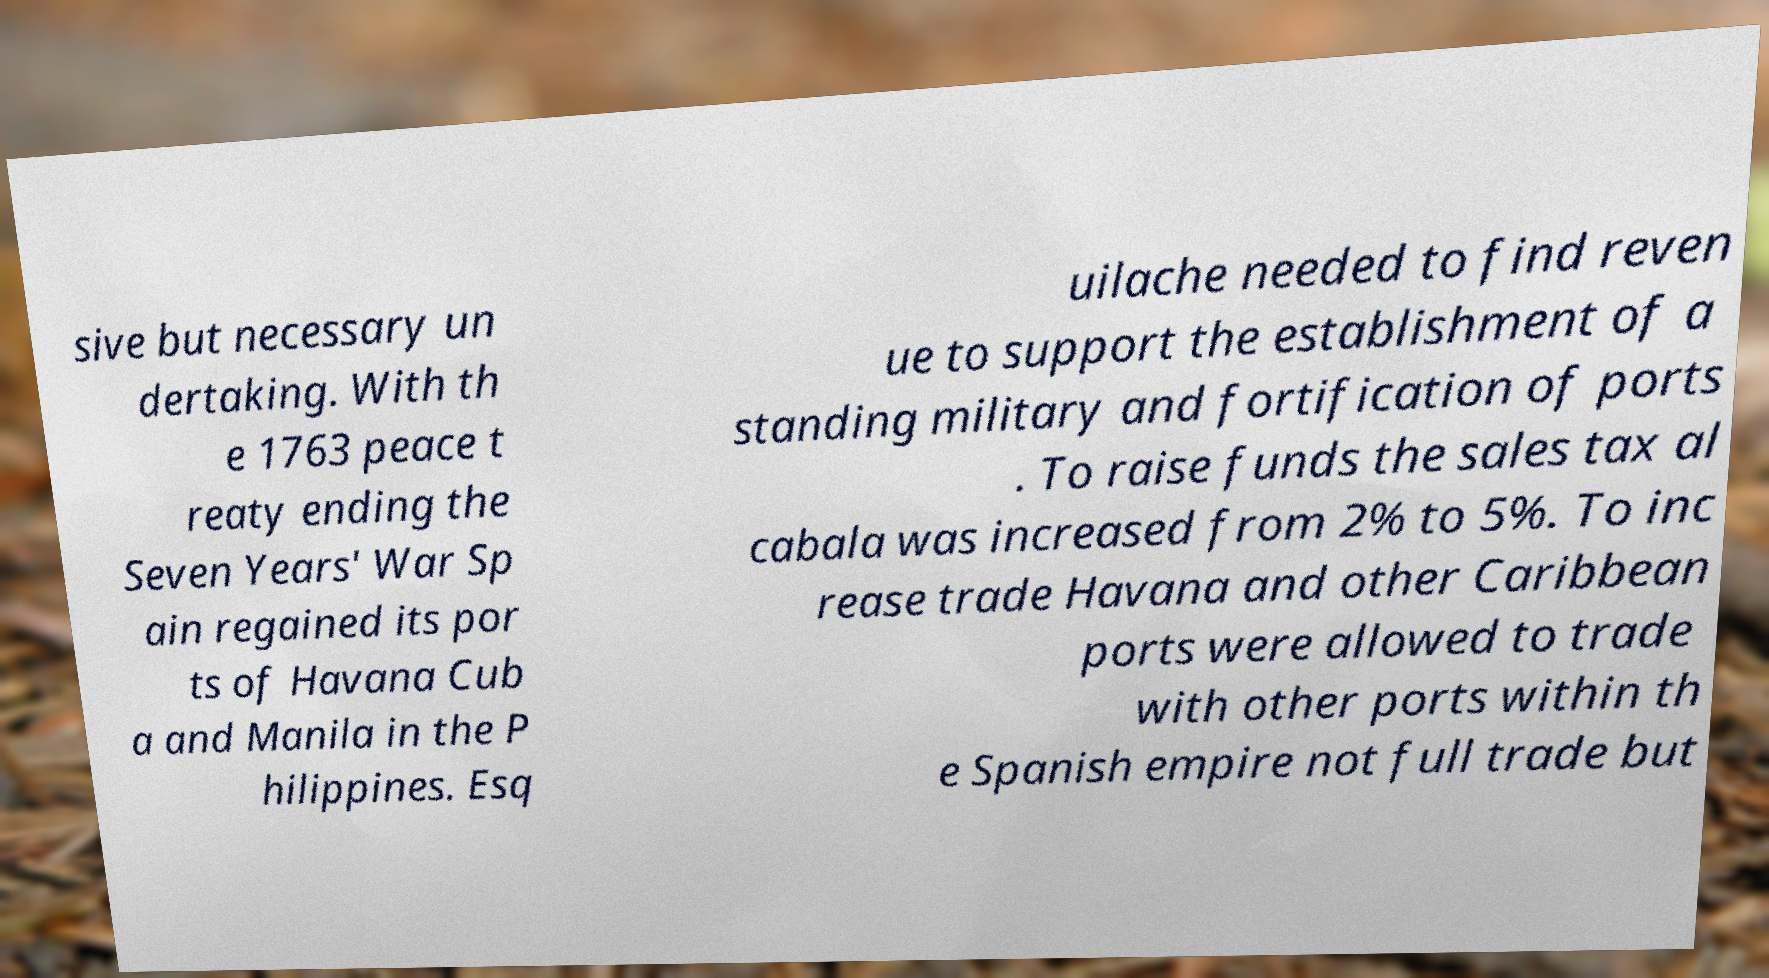Please identify and transcribe the text found in this image. sive but necessary un dertaking. With th e 1763 peace t reaty ending the Seven Years' War Sp ain regained its por ts of Havana Cub a and Manila in the P hilippines. Esq uilache needed to find reven ue to support the establishment of a standing military and fortification of ports . To raise funds the sales tax al cabala was increased from 2% to 5%. To inc rease trade Havana and other Caribbean ports were allowed to trade with other ports within th e Spanish empire not full trade but 